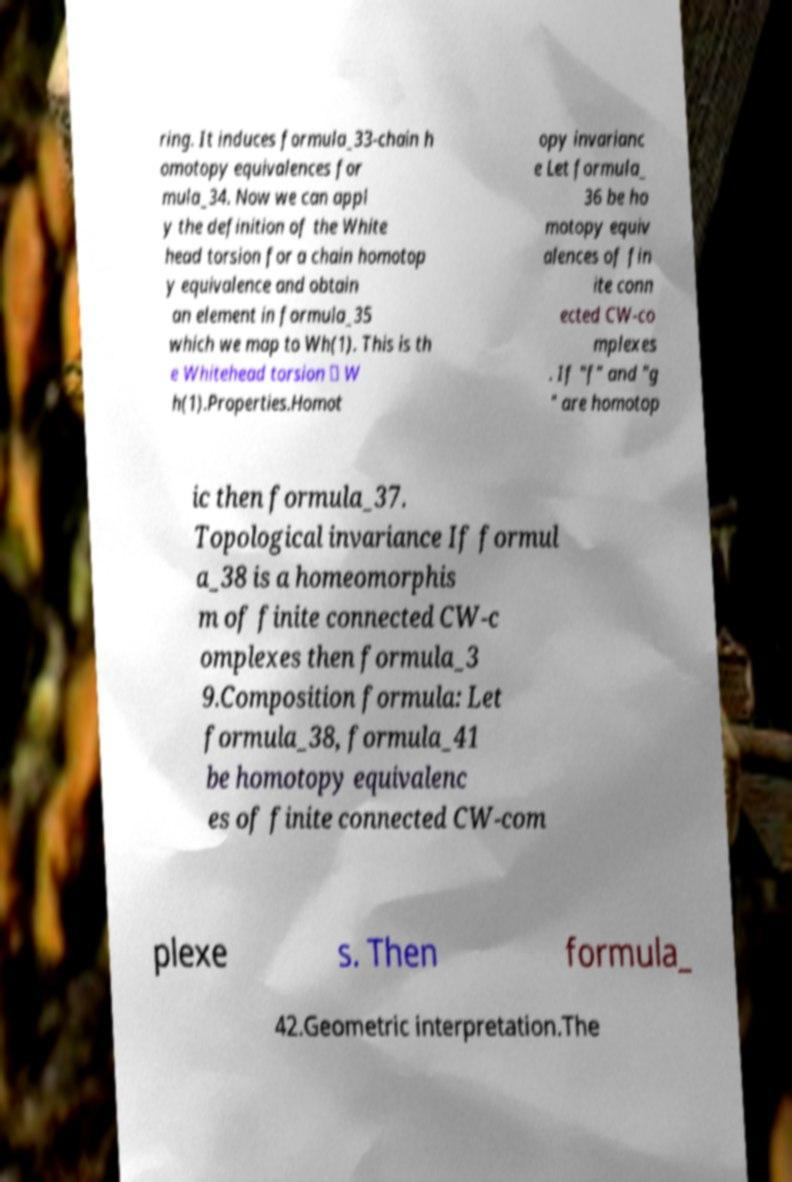Could you assist in decoding the text presented in this image and type it out clearly? ring. It induces formula_33-chain h omotopy equivalences for mula_34. Now we can appl y the definition of the White head torsion for a chain homotop y equivalence and obtain an element in formula_35 which we map to Wh(1). This is th e Whitehead torsion ∈ W h(1).Properties.Homot opy invarianc e Let formula_ 36 be ho motopy equiv alences of fin ite conn ected CW-co mplexes . If "f" and "g " are homotop ic then formula_37. Topological invariance If formul a_38 is a homeomorphis m of finite connected CW-c omplexes then formula_3 9.Composition formula: Let formula_38, formula_41 be homotopy equivalenc es of finite connected CW-com plexe s. Then formula_ 42.Geometric interpretation.The 